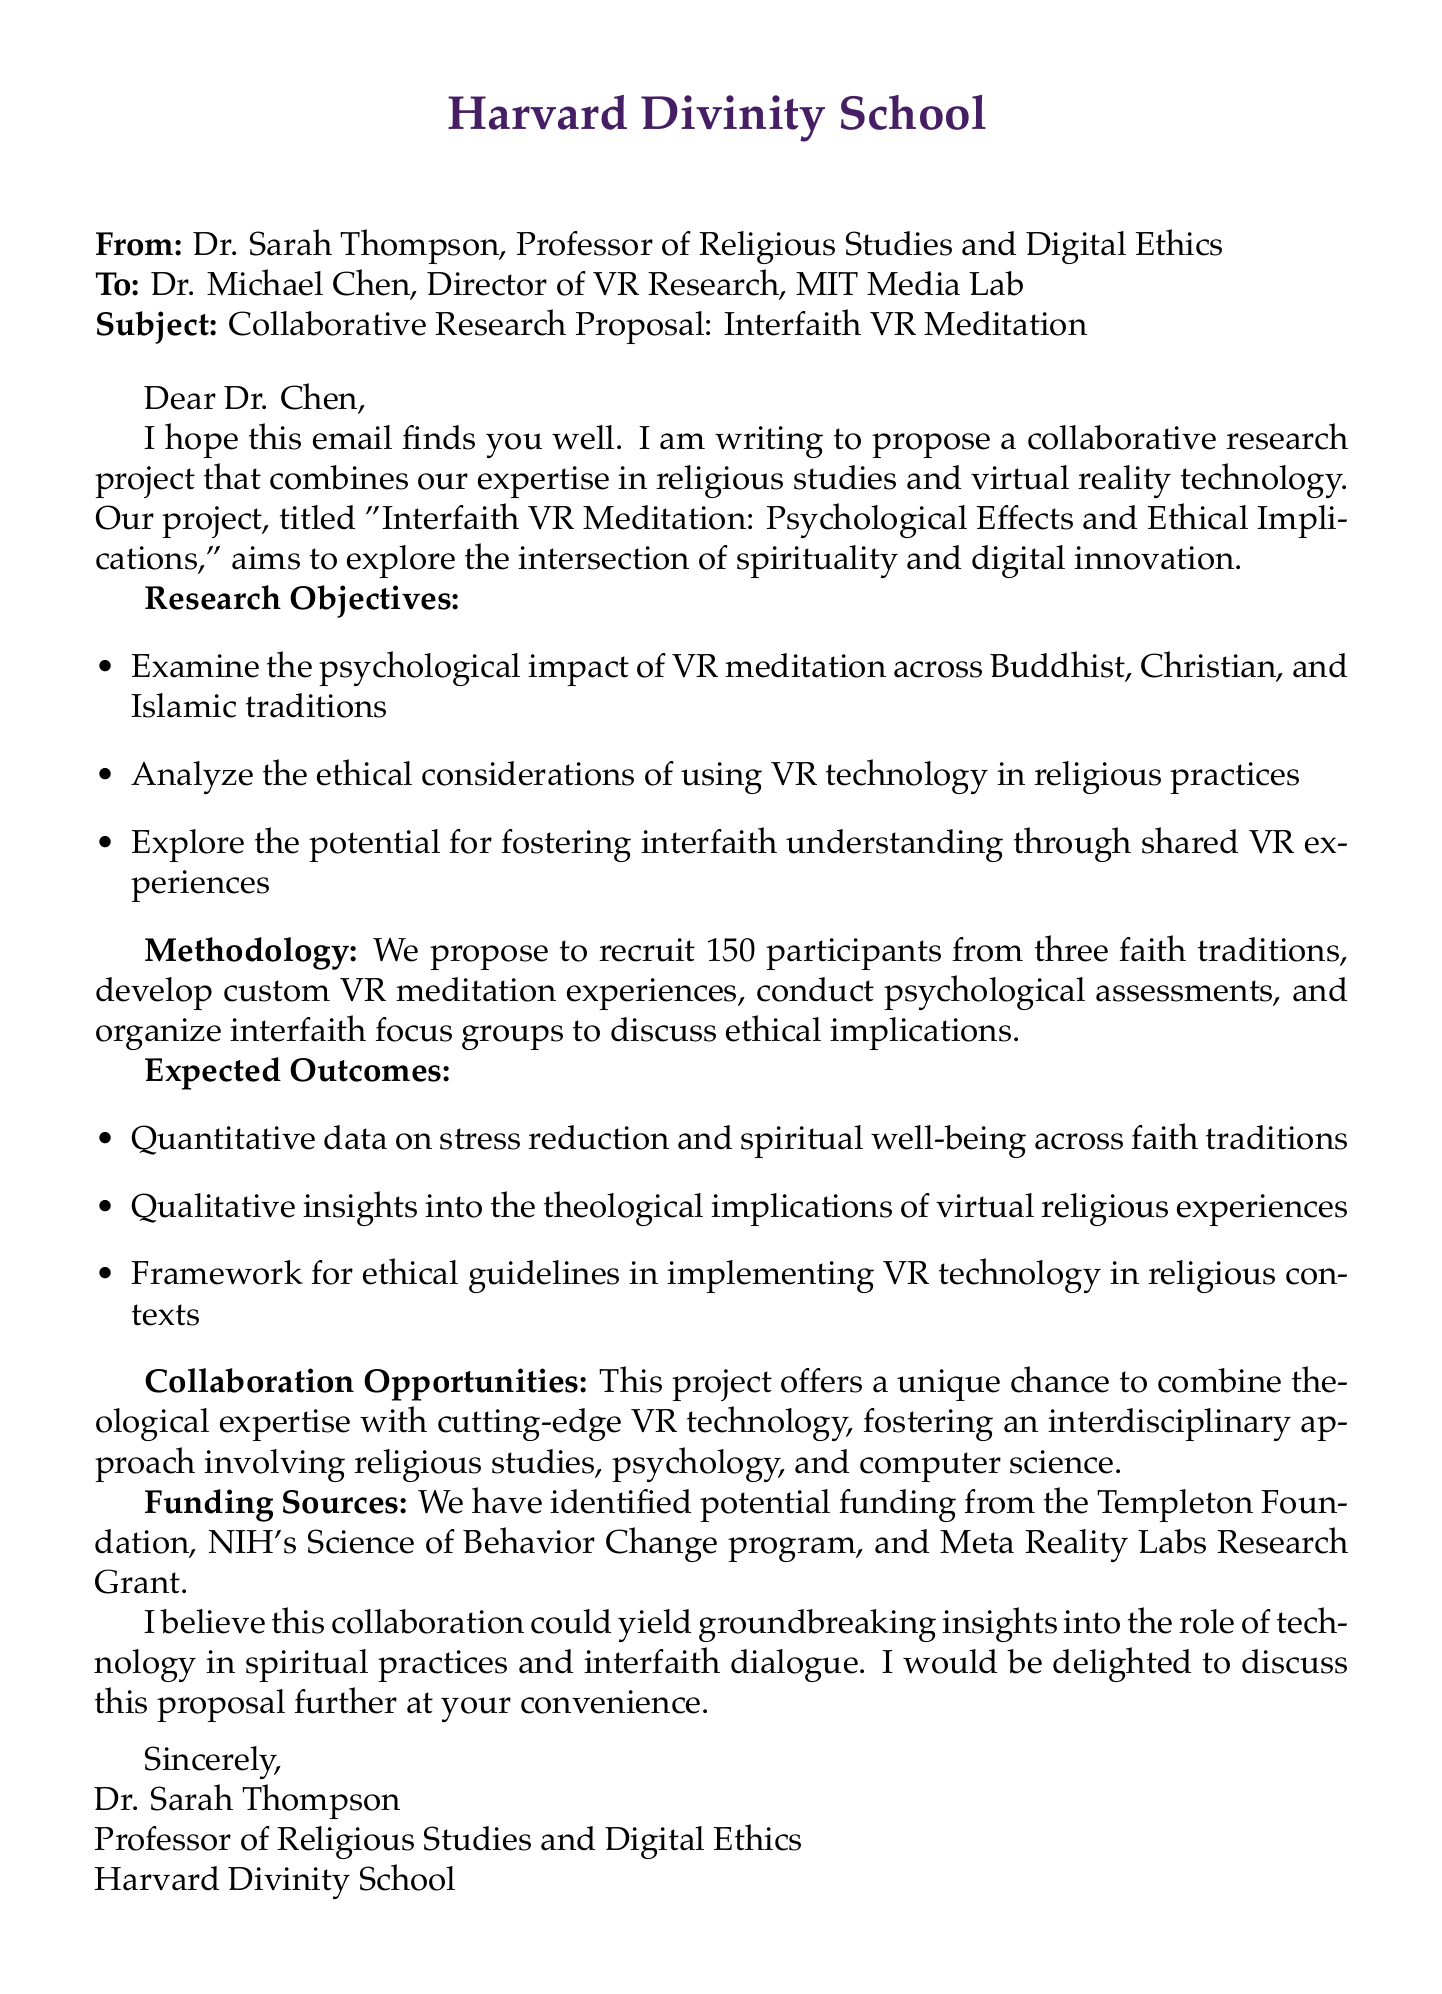What is the title of the project? The title of the project is explicitly mentioned in the document, which is "Interfaith VR Meditation: Psychological Effects and Ethical Implications."
Answer: Interfaith VR Meditation: Psychological Effects and Ethical Implications Who is the sender of the email? The sender of the email is identified as Dr. Sarah Thompson, whose title and position are also specified.
Answer: Dr. Sarah Thompson How many participants are proposed to be recruited from each faith tradition? The document states that 50 participants will be recruited from each of the three faith traditions involved in the study.
Answer: 50 What is one of the expected outcomes of the research? The document lists several expected outcomes, one of which is quantitative data on stress reduction and spiritual well-being across faith traditions.
Answer: Quantitative data on stress reduction and spiritual well-being across faith traditions What are the three faith traditions being studied? The email outlines that the study will focus on Buddhism, Christianity, and Islam as the three faith traditions.
Answer: Buddhist, Christian, and Islamic Which foundation is mentioned as a potential funding source? The document includes the Templeton Foundation as one of the identified potential funding sources for the project.
Answer: Templeton Foundation What type of approach is suggested for the collaboration? The email mentions an interdisciplinary approach that involves multiple fields of study.
Answer: Interdisciplinary approach What is one of the potential challenges listed in the proposal? The document highlights the challenge of ensuring authentic representation of religious practices in the VR experiences as a potential issue to address.
Answer: Ensuring authentic representation of religious practices in VR 